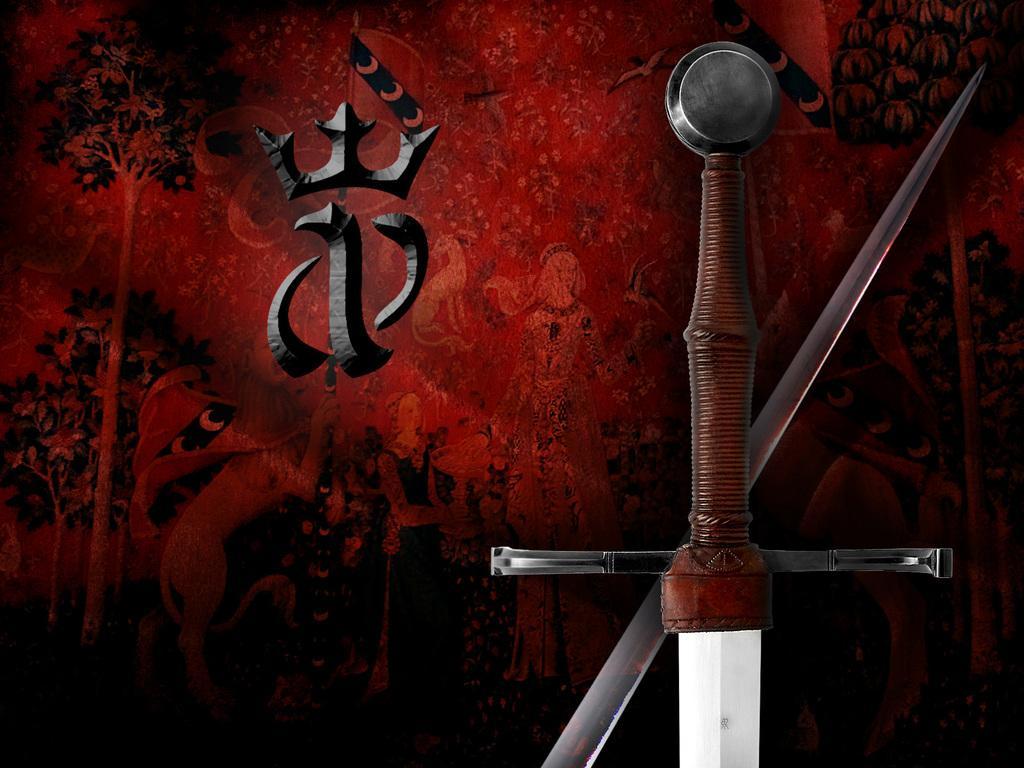Describe this image in one or two sentences. Here in this picture we can see an animated image of a sword and behind it we can see a red and black background with something written over there and we can see trees also present here and there in that background. 